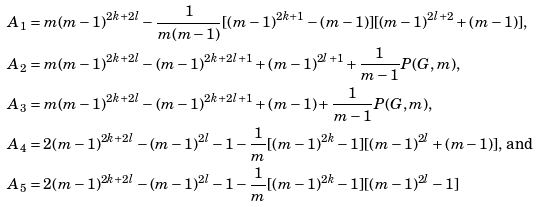Convert formula to latex. <formula><loc_0><loc_0><loc_500><loc_500>& A _ { 1 } = m ( m - 1 ) ^ { 2 k + 2 l } - \frac { 1 } { m ( m - 1 ) } [ ( m - 1 ) ^ { 2 k + 1 } - ( m - 1 ) ] [ ( m - 1 ) ^ { 2 l + 2 } + ( m - 1 ) ] , \\ & A _ { 2 } = m ( m - 1 ) ^ { 2 k + 2 l } - ( m - 1 ) ^ { 2 k + 2 l + 1 } + ( m - 1 ) ^ { 2 l + 1 } + \frac { 1 } { m - 1 } P ( G , m ) , \\ & A _ { 3 } = m ( m - 1 ) ^ { 2 k + 2 l } - ( m - 1 ) ^ { 2 k + 2 l + 1 } + ( m - 1 ) + \frac { 1 } { m - 1 } P ( G , m ) , \\ & A _ { 4 } = 2 ( m - 1 ) ^ { 2 k + 2 l } - ( m - 1 ) ^ { 2 l } - 1 - \frac { 1 } { m } [ ( m - 1 ) ^ { 2 k } - 1 ] [ ( m - 1 ) ^ { 2 l } + ( m - 1 ) ] , \, \text {and} \\ & A _ { 5 } = 2 ( m - 1 ) ^ { 2 k + 2 l } - ( m - 1 ) ^ { 2 l } - 1 - \frac { 1 } { m } [ ( m - 1 ) ^ { 2 k } - 1 ] [ ( m - 1 ) ^ { 2 l } - 1 ]</formula> 